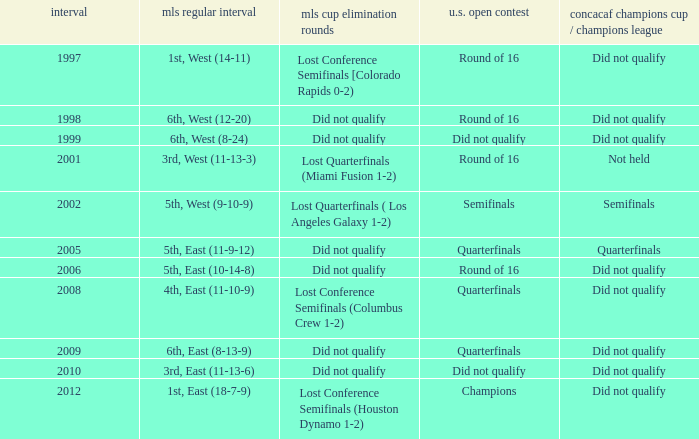When was the first season? 1997.0. 